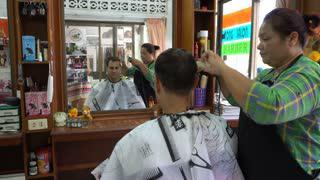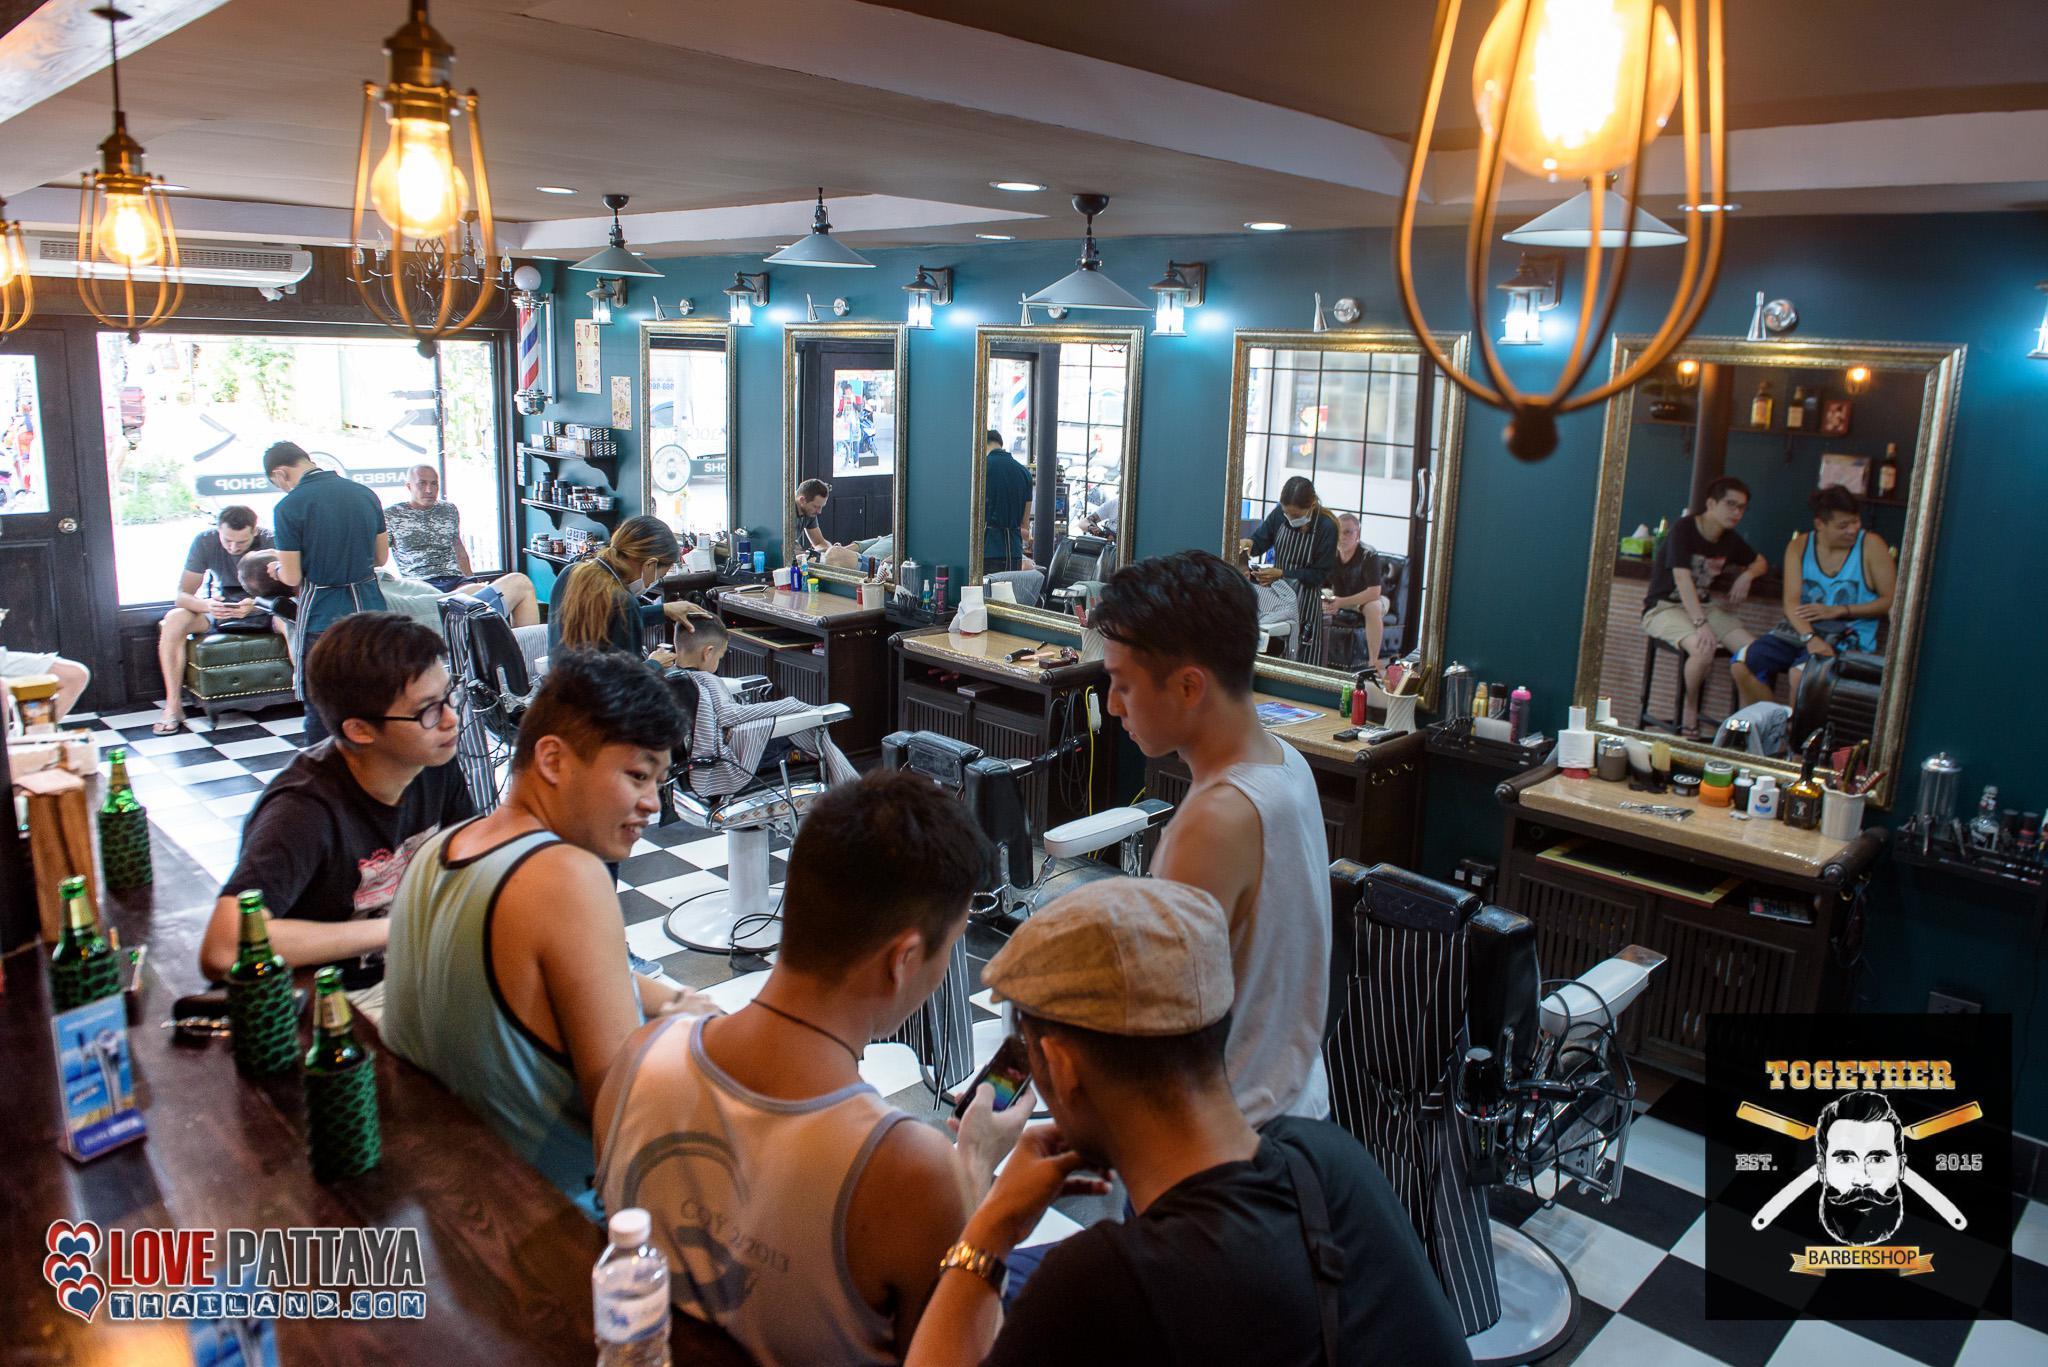The first image is the image on the left, the second image is the image on the right. Examine the images to the left and right. Is the description "There is a total of five people include the different image reflected in the mirror." accurate? Answer yes or no. No. The first image is the image on the left, the second image is the image on the right. Examine the images to the left and right. Is the description "Five humans are visible." accurate? Answer yes or no. No. 